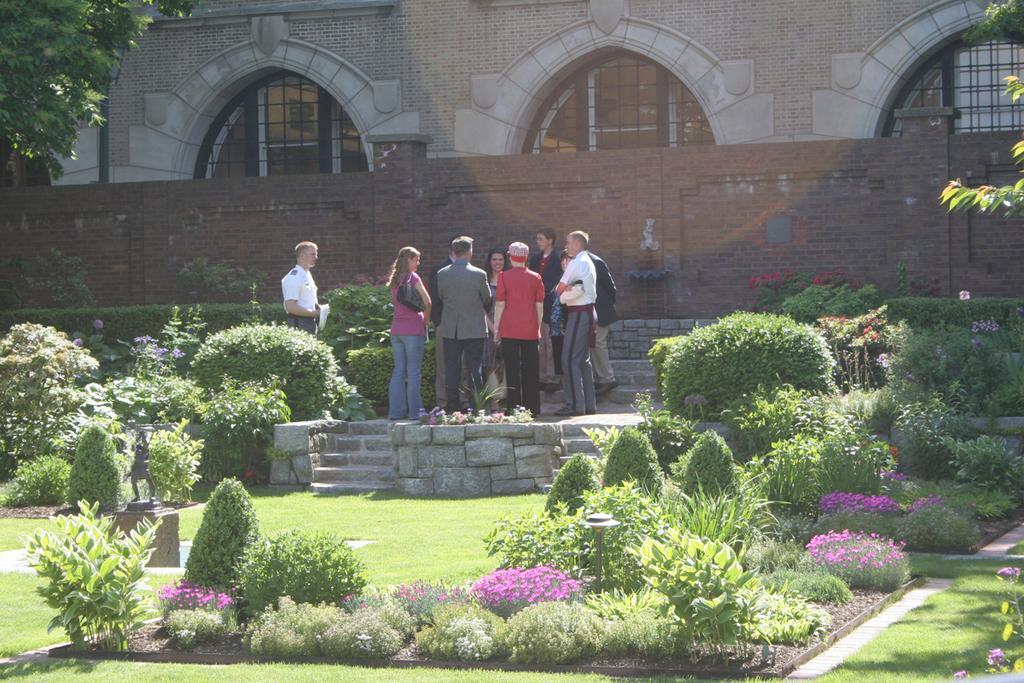Please provide a concise description of this image. In this picture I can see many persons who are standing near to the plants. In the back I can see the building and wall partition. At the bottom I can see some pink color flowers on the plant, beside that I can see the grass. On the left there is a statue which is placed on the stone. In the top left corner I can see the tree. 